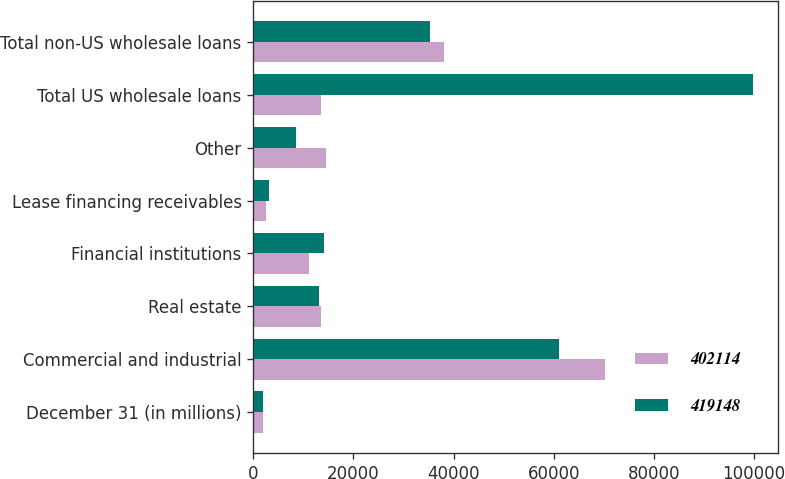Convert chart to OTSL. <chart><loc_0><loc_0><loc_500><loc_500><stacked_bar_chart><ecel><fcel>December 31 (in millions)<fcel>Commercial and industrial<fcel>Real estate<fcel>Financial institutions<fcel>Lease financing receivables<fcel>Other<fcel>Total US wholesale loans<fcel>Total non-US wholesale loans<nl><fcel>402114<fcel>2005<fcel>70233<fcel>13612<fcel>11100<fcel>2621<fcel>14499<fcel>13612<fcel>38046<nl><fcel>419148<fcel>2004<fcel>61033<fcel>13038<fcel>14195<fcel>3098<fcel>8504<fcel>99868<fcel>35199<nl></chart> 